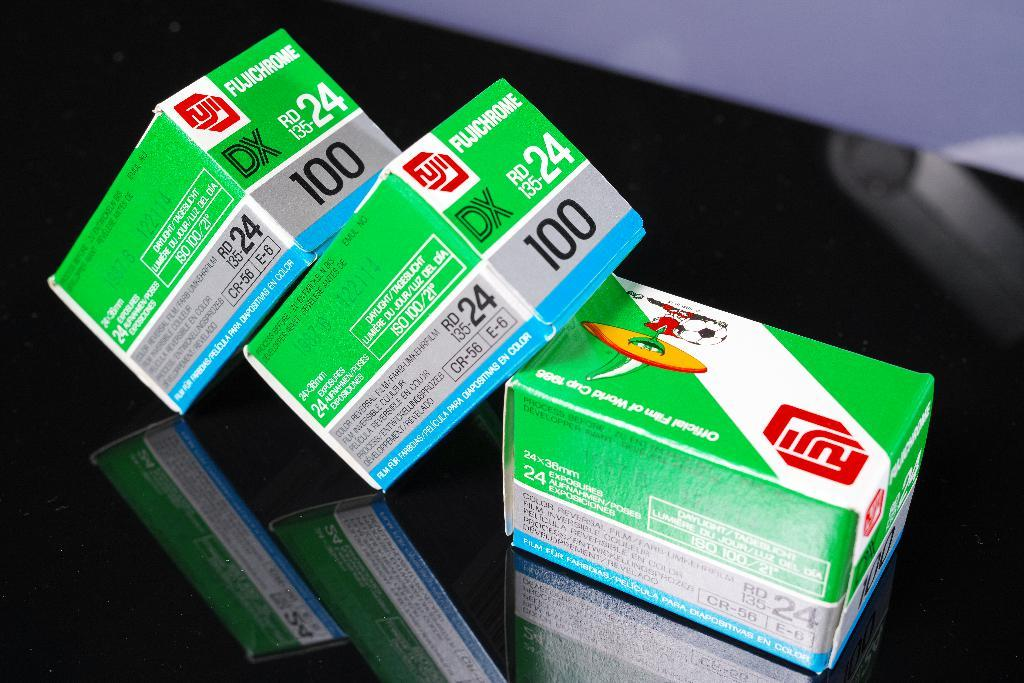<image>
Give a short and clear explanation of the subsequent image. 3 boxes of Fujichrome film are on a black table. 